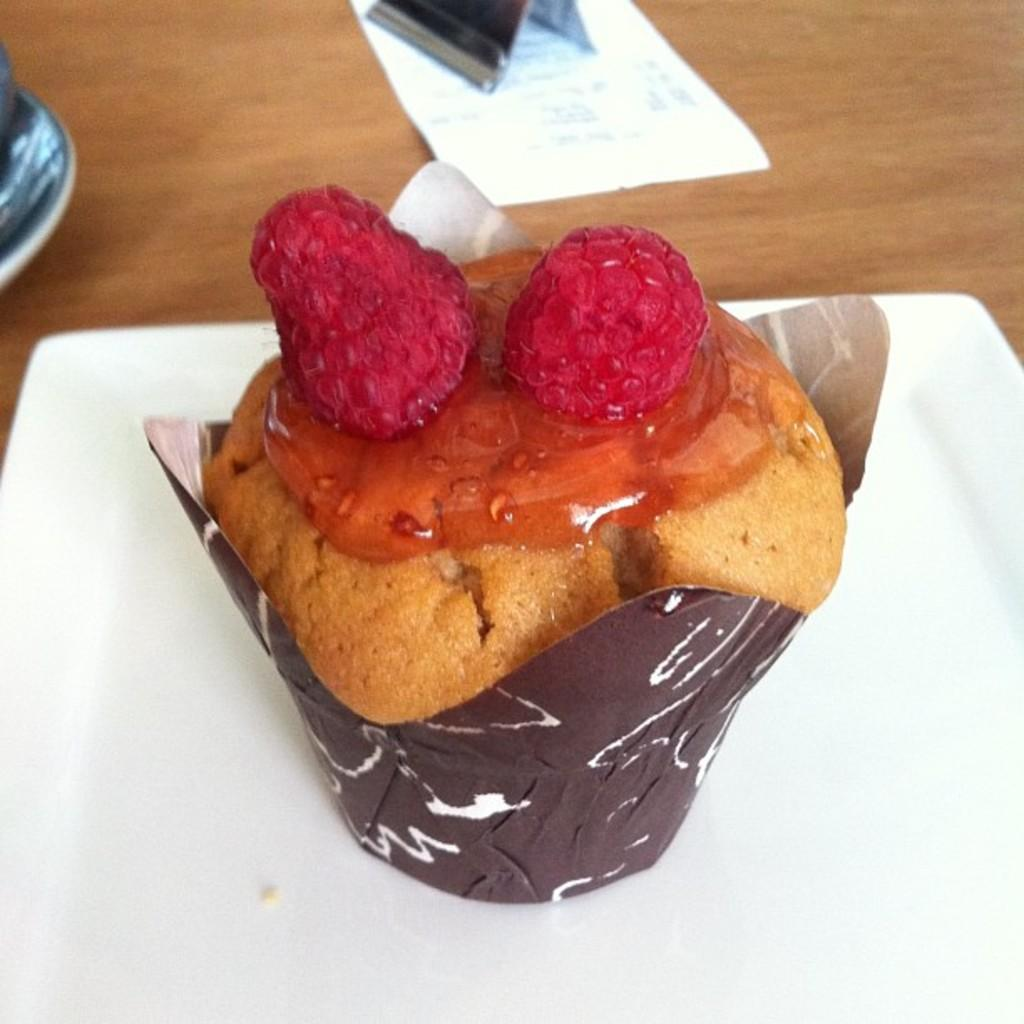What type of furniture is present in the image? There is a table in the image. What objects are placed on the table? There are plates, paper, and a paperweight on the table. What might be used to hold down the paper on the table? There is a paperweight on the table. What type of food item is visible on the table? There is a food item on the table. What type of pet is visible on the table in the image? There is no pet visible on the table in the image. What type of system is being used to serve the dinner in the image? The image does not show a dinner or any system being used to serve it. 